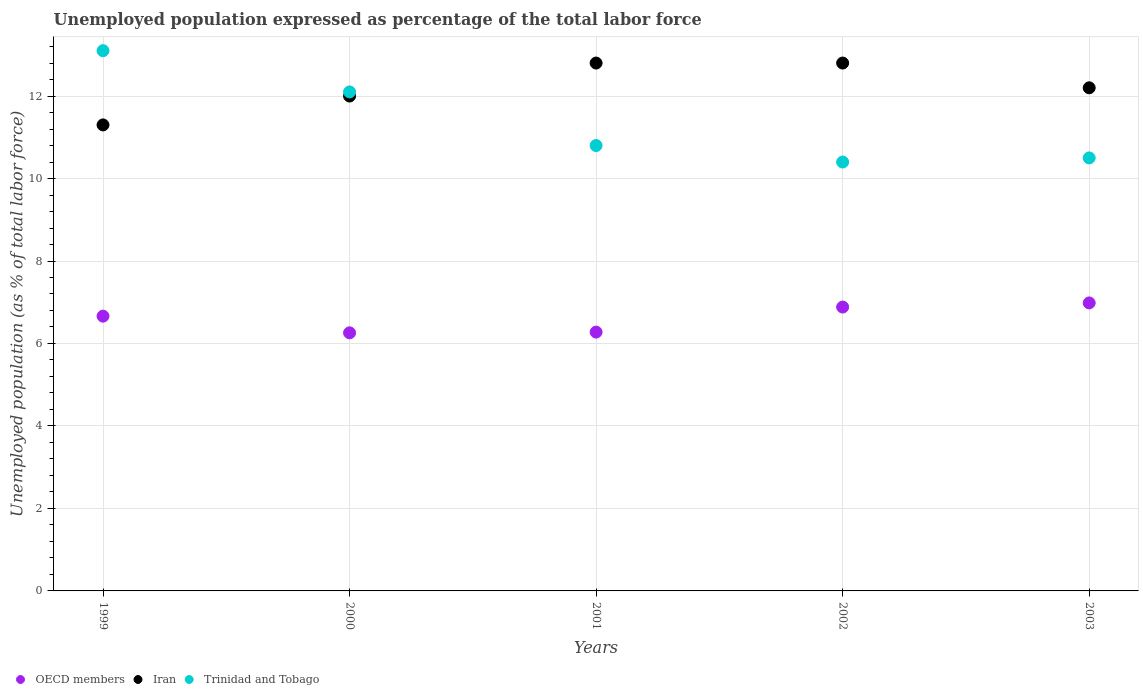What is the unemployment in in Iran in 2001?
Ensure brevity in your answer.  12.8. Across all years, what is the maximum unemployment in in OECD members?
Offer a very short reply. 6.98. Across all years, what is the minimum unemployment in in OECD members?
Offer a terse response. 6.26. In which year was the unemployment in in Trinidad and Tobago maximum?
Ensure brevity in your answer.  1999. What is the total unemployment in in Iran in the graph?
Keep it short and to the point. 61.1. What is the difference between the unemployment in in Trinidad and Tobago in 2000 and that in 2003?
Offer a very short reply. 1.6. What is the difference between the unemployment in in Trinidad and Tobago in 2002 and the unemployment in in OECD members in 1999?
Keep it short and to the point. 3.74. What is the average unemployment in in OECD members per year?
Your response must be concise. 6.61. In the year 1999, what is the difference between the unemployment in in Trinidad and Tobago and unemployment in in OECD members?
Your response must be concise. 6.44. What is the ratio of the unemployment in in OECD members in 2002 to that in 2003?
Offer a terse response. 0.99. Is the difference between the unemployment in in Trinidad and Tobago in 2001 and 2003 greater than the difference between the unemployment in in OECD members in 2001 and 2003?
Your response must be concise. Yes. What is the difference between the highest and the second highest unemployment in in OECD members?
Offer a terse response. 0.1. Is the sum of the unemployment in in Iran in 2001 and 2003 greater than the maximum unemployment in in OECD members across all years?
Offer a very short reply. Yes. Is it the case that in every year, the sum of the unemployment in in Iran and unemployment in in Trinidad and Tobago  is greater than the unemployment in in OECD members?
Your answer should be very brief. Yes. Does the unemployment in in Trinidad and Tobago monotonically increase over the years?
Offer a terse response. No. Is the unemployment in in Iran strictly greater than the unemployment in in Trinidad and Tobago over the years?
Offer a very short reply. No. What is the difference between two consecutive major ticks on the Y-axis?
Provide a short and direct response. 2. Where does the legend appear in the graph?
Ensure brevity in your answer.  Bottom left. What is the title of the graph?
Your answer should be compact. Unemployed population expressed as percentage of the total labor force. Does "Curacao" appear as one of the legend labels in the graph?
Your response must be concise. No. What is the label or title of the Y-axis?
Give a very brief answer. Unemployed population (as % of total labor force). What is the Unemployed population (as % of total labor force) in OECD members in 1999?
Your response must be concise. 6.66. What is the Unemployed population (as % of total labor force) of Iran in 1999?
Keep it short and to the point. 11.3. What is the Unemployed population (as % of total labor force) in Trinidad and Tobago in 1999?
Your answer should be very brief. 13.1. What is the Unemployed population (as % of total labor force) of OECD members in 2000?
Your answer should be very brief. 6.26. What is the Unemployed population (as % of total labor force) in Trinidad and Tobago in 2000?
Keep it short and to the point. 12.1. What is the Unemployed population (as % of total labor force) of OECD members in 2001?
Ensure brevity in your answer.  6.28. What is the Unemployed population (as % of total labor force) in Iran in 2001?
Make the answer very short. 12.8. What is the Unemployed population (as % of total labor force) in Trinidad and Tobago in 2001?
Ensure brevity in your answer.  10.8. What is the Unemployed population (as % of total labor force) of OECD members in 2002?
Ensure brevity in your answer.  6.88. What is the Unemployed population (as % of total labor force) of Iran in 2002?
Provide a succinct answer. 12.8. What is the Unemployed population (as % of total labor force) of Trinidad and Tobago in 2002?
Ensure brevity in your answer.  10.4. What is the Unemployed population (as % of total labor force) in OECD members in 2003?
Your response must be concise. 6.98. What is the Unemployed population (as % of total labor force) in Iran in 2003?
Give a very brief answer. 12.2. What is the Unemployed population (as % of total labor force) in Trinidad and Tobago in 2003?
Provide a succinct answer. 10.5. Across all years, what is the maximum Unemployed population (as % of total labor force) of OECD members?
Provide a succinct answer. 6.98. Across all years, what is the maximum Unemployed population (as % of total labor force) of Iran?
Ensure brevity in your answer.  12.8. Across all years, what is the maximum Unemployed population (as % of total labor force) of Trinidad and Tobago?
Ensure brevity in your answer.  13.1. Across all years, what is the minimum Unemployed population (as % of total labor force) in OECD members?
Offer a very short reply. 6.26. Across all years, what is the minimum Unemployed population (as % of total labor force) in Iran?
Give a very brief answer. 11.3. Across all years, what is the minimum Unemployed population (as % of total labor force) in Trinidad and Tobago?
Ensure brevity in your answer.  10.4. What is the total Unemployed population (as % of total labor force) of OECD members in the graph?
Your answer should be very brief. 33.06. What is the total Unemployed population (as % of total labor force) of Iran in the graph?
Your response must be concise. 61.1. What is the total Unemployed population (as % of total labor force) in Trinidad and Tobago in the graph?
Your answer should be very brief. 56.9. What is the difference between the Unemployed population (as % of total labor force) of OECD members in 1999 and that in 2000?
Your response must be concise. 0.4. What is the difference between the Unemployed population (as % of total labor force) in OECD members in 1999 and that in 2001?
Provide a succinct answer. 0.39. What is the difference between the Unemployed population (as % of total labor force) in Trinidad and Tobago in 1999 and that in 2001?
Your answer should be very brief. 2.3. What is the difference between the Unemployed population (as % of total labor force) of OECD members in 1999 and that in 2002?
Provide a succinct answer. -0.22. What is the difference between the Unemployed population (as % of total labor force) of Trinidad and Tobago in 1999 and that in 2002?
Provide a short and direct response. 2.7. What is the difference between the Unemployed population (as % of total labor force) in OECD members in 1999 and that in 2003?
Your answer should be very brief. -0.32. What is the difference between the Unemployed population (as % of total labor force) of Iran in 1999 and that in 2003?
Your response must be concise. -0.9. What is the difference between the Unemployed population (as % of total labor force) in OECD members in 2000 and that in 2001?
Your response must be concise. -0.02. What is the difference between the Unemployed population (as % of total labor force) of Iran in 2000 and that in 2001?
Your answer should be very brief. -0.8. What is the difference between the Unemployed population (as % of total labor force) in OECD members in 2000 and that in 2002?
Make the answer very short. -0.62. What is the difference between the Unemployed population (as % of total labor force) of OECD members in 2000 and that in 2003?
Give a very brief answer. -0.72. What is the difference between the Unemployed population (as % of total labor force) in Trinidad and Tobago in 2000 and that in 2003?
Provide a succinct answer. 1.6. What is the difference between the Unemployed population (as % of total labor force) of OECD members in 2001 and that in 2002?
Ensure brevity in your answer.  -0.61. What is the difference between the Unemployed population (as % of total labor force) of Iran in 2001 and that in 2002?
Keep it short and to the point. 0. What is the difference between the Unemployed population (as % of total labor force) in Trinidad and Tobago in 2001 and that in 2002?
Offer a very short reply. 0.4. What is the difference between the Unemployed population (as % of total labor force) in OECD members in 2001 and that in 2003?
Your response must be concise. -0.71. What is the difference between the Unemployed population (as % of total labor force) of Iran in 2001 and that in 2003?
Provide a succinct answer. 0.6. What is the difference between the Unemployed population (as % of total labor force) in Trinidad and Tobago in 2001 and that in 2003?
Ensure brevity in your answer.  0.3. What is the difference between the Unemployed population (as % of total labor force) in OECD members in 2002 and that in 2003?
Keep it short and to the point. -0.1. What is the difference between the Unemployed population (as % of total labor force) in Iran in 2002 and that in 2003?
Give a very brief answer. 0.6. What is the difference between the Unemployed population (as % of total labor force) in Trinidad and Tobago in 2002 and that in 2003?
Your answer should be very brief. -0.1. What is the difference between the Unemployed population (as % of total labor force) in OECD members in 1999 and the Unemployed population (as % of total labor force) in Iran in 2000?
Make the answer very short. -5.34. What is the difference between the Unemployed population (as % of total labor force) of OECD members in 1999 and the Unemployed population (as % of total labor force) of Trinidad and Tobago in 2000?
Keep it short and to the point. -5.44. What is the difference between the Unemployed population (as % of total labor force) of OECD members in 1999 and the Unemployed population (as % of total labor force) of Iran in 2001?
Offer a terse response. -6.14. What is the difference between the Unemployed population (as % of total labor force) of OECD members in 1999 and the Unemployed population (as % of total labor force) of Trinidad and Tobago in 2001?
Offer a terse response. -4.14. What is the difference between the Unemployed population (as % of total labor force) of Iran in 1999 and the Unemployed population (as % of total labor force) of Trinidad and Tobago in 2001?
Offer a terse response. 0.5. What is the difference between the Unemployed population (as % of total labor force) in OECD members in 1999 and the Unemployed population (as % of total labor force) in Iran in 2002?
Provide a succinct answer. -6.14. What is the difference between the Unemployed population (as % of total labor force) in OECD members in 1999 and the Unemployed population (as % of total labor force) in Trinidad and Tobago in 2002?
Offer a terse response. -3.74. What is the difference between the Unemployed population (as % of total labor force) of Iran in 1999 and the Unemployed population (as % of total labor force) of Trinidad and Tobago in 2002?
Keep it short and to the point. 0.9. What is the difference between the Unemployed population (as % of total labor force) of OECD members in 1999 and the Unemployed population (as % of total labor force) of Iran in 2003?
Your answer should be compact. -5.54. What is the difference between the Unemployed population (as % of total labor force) in OECD members in 1999 and the Unemployed population (as % of total labor force) in Trinidad and Tobago in 2003?
Your answer should be very brief. -3.84. What is the difference between the Unemployed population (as % of total labor force) of OECD members in 2000 and the Unemployed population (as % of total labor force) of Iran in 2001?
Your answer should be compact. -6.54. What is the difference between the Unemployed population (as % of total labor force) in OECD members in 2000 and the Unemployed population (as % of total labor force) in Trinidad and Tobago in 2001?
Offer a terse response. -4.54. What is the difference between the Unemployed population (as % of total labor force) of Iran in 2000 and the Unemployed population (as % of total labor force) of Trinidad and Tobago in 2001?
Make the answer very short. 1.2. What is the difference between the Unemployed population (as % of total labor force) in OECD members in 2000 and the Unemployed population (as % of total labor force) in Iran in 2002?
Your response must be concise. -6.54. What is the difference between the Unemployed population (as % of total labor force) of OECD members in 2000 and the Unemployed population (as % of total labor force) of Trinidad and Tobago in 2002?
Make the answer very short. -4.14. What is the difference between the Unemployed population (as % of total labor force) in Iran in 2000 and the Unemployed population (as % of total labor force) in Trinidad and Tobago in 2002?
Keep it short and to the point. 1.6. What is the difference between the Unemployed population (as % of total labor force) of OECD members in 2000 and the Unemployed population (as % of total labor force) of Iran in 2003?
Give a very brief answer. -5.94. What is the difference between the Unemployed population (as % of total labor force) of OECD members in 2000 and the Unemployed population (as % of total labor force) of Trinidad and Tobago in 2003?
Give a very brief answer. -4.24. What is the difference between the Unemployed population (as % of total labor force) of OECD members in 2001 and the Unemployed population (as % of total labor force) of Iran in 2002?
Your answer should be very brief. -6.52. What is the difference between the Unemployed population (as % of total labor force) in OECD members in 2001 and the Unemployed population (as % of total labor force) in Trinidad and Tobago in 2002?
Provide a succinct answer. -4.12. What is the difference between the Unemployed population (as % of total labor force) in OECD members in 2001 and the Unemployed population (as % of total labor force) in Iran in 2003?
Offer a very short reply. -5.92. What is the difference between the Unemployed population (as % of total labor force) of OECD members in 2001 and the Unemployed population (as % of total labor force) of Trinidad and Tobago in 2003?
Provide a succinct answer. -4.22. What is the difference between the Unemployed population (as % of total labor force) in OECD members in 2002 and the Unemployed population (as % of total labor force) in Iran in 2003?
Offer a terse response. -5.32. What is the difference between the Unemployed population (as % of total labor force) of OECD members in 2002 and the Unemployed population (as % of total labor force) of Trinidad and Tobago in 2003?
Keep it short and to the point. -3.62. What is the average Unemployed population (as % of total labor force) in OECD members per year?
Your response must be concise. 6.61. What is the average Unemployed population (as % of total labor force) in Iran per year?
Offer a very short reply. 12.22. What is the average Unemployed population (as % of total labor force) of Trinidad and Tobago per year?
Provide a succinct answer. 11.38. In the year 1999, what is the difference between the Unemployed population (as % of total labor force) of OECD members and Unemployed population (as % of total labor force) of Iran?
Offer a terse response. -4.64. In the year 1999, what is the difference between the Unemployed population (as % of total labor force) in OECD members and Unemployed population (as % of total labor force) in Trinidad and Tobago?
Offer a terse response. -6.44. In the year 2000, what is the difference between the Unemployed population (as % of total labor force) in OECD members and Unemployed population (as % of total labor force) in Iran?
Provide a short and direct response. -5.74. In the year 2000, what is the difference between the Unemployed population (as % of total labor force) in OECD members and Unemployed population (as % of total labor force) in Trinidad and Tobago?
Ensure brevity in your answer.  -5.84. In the year 2000, what is the difference between the Unemployed population (as % of total labor force) in Iran and Unemployed population (as % of total labor force) in Trinidad and Tobago?
Ensure brevity in your answer.  -0.1. In the year 2001, what is the difference between the Unemployed population (as % of total labor force) in OECD members and Unemployed population (as % of total labor force) in Iran?
Give a very brief answer. -6.52. In the year 2001, what is the difference between the Unemployed population (as % of total labor force) in OECD members and Unemployed population (as % of total labor force) in Trinidad and Tobago?
Your answer should be compact. -4.52. In the year 2002, what is the difference between the Unemployed population (as % of total labor force) in OECD members and Unemployed population (as % of total labor force) in Iran?
Offer a terse response. -5.92. In the year 2002, what is the difference between the Unemployed population (as % of total labor force) in OECD members and Unemployed population (as % of total labor force) in Trinidad and Tobago?
Make the answer very short. -3.52. In the year 2003, what is the difference between the Unemployed population (as % of total labor force) in OECD members and Unemployed population (as % of total labor force) in Iran?
Keep it short and to the point. -5.22. In the year 2003, what is the difference between the Unemployed population (as % of total labor force) of OECD members and Unemployed population (as % of total labor force) of Trinidad and Tobago?
Give a very brief answer. -3.52. What is the ratio of the Unemployed population (as % of total labor force) of OECD members in 1999 to that in 2000?
Your response must be concise. 1.06. What is the ratio of the Unemployed population (as % of total labor force) in Iran in 1999 to that in 2000?
Ensure brevity in your answer.  0.94. What is the ratio of the Unemployed population (as % of total labor force) in Trinidad and Tobago in 1999 to that in 2000?
Make the answer very short. 1.08. What is the ratio of the Unemployed population (as % of total labor force) of OECD members in 1999 to that in 2001?
Provide a succinct answer. 1.06. What is the ratio of the Unemployed population (as % of total labor force) of Iran in 1999 to that in 2001?
Provide a succinct answer. 0.88. What is the ratio of the Unemployed population (as % of total labor force) of Trinidad and Tobago in 1999 to that in 2001?
Provide a succinct answer. 1.21. What is the ratio of the Unemployed population (as % of total labor force) of OECD members in 1999 to that in 2002?
Your answer should be compact. 0.97. What is the ratio of the Unemployed population (as % of total labor force) of Iran in 1999 to that in 2002?
Your answer should be very brief. 0.88. What is the ratio of the Unemployed population (as % of total labor force) in Trinidad and Tobago in 1999 to that in 2002?
Keep it short and to the point. 1.26. What is the ratio of the Unemployed population (as % of total labor force) in OECD members in 1999 to that in 2003?
Offer a very short reply. 0.95. What is the ratio of the Unemployed population (as % of total labor force) of Iran in 1999 to that in 2003?
Your answer should be compact. 0.93. What is the ratio of the Unemployed population (as % of total labor force) in Trinidad and Tobago in 1999 to that in 2003?
Provide a succinct answer. 1.25. What is the ratio of the Unemployed population (as % of total labor force) in Trinidad and Tobago in 2000 to that in 2001?
Offer a very short reply. 1.12. What is the ratio of the Unemployed population (as % of total labor force) in OECD members in 2000 to that in 2002?
Keep it short and to the point. 0.91. What is the ratio of the Unemployed population (as % of total labor force) of Trinidad and Tobago in 2000 to that in 2002?
Keep it short and to the point. 1.16. What is the ratio of the Unemployed population (as % of total labor force) of OECD members in 2000 to that in 2003?
Keep it short and to the point. 0.9. What is the ratio of the Unemployed population (as % of total labor force) of Iran in 2000 to that in 2003?
Provide a succinct answer. 0.98. What is the ratio of the Unemployed population (as % of total labor force) of Trinidad and Tobago in 2000 to that in 2003?
Give a very brief answer. 1.15. What is the ratio of the Unemployed population (as % of total labor force) in OECD members in 2001 to that in 2002?
Keep it short and to the point. 0.91. What is the ratio of the Unemployed population (as % of total labor force) of OECD members in 2001 to that in 2003?
Offer a very short reply. 0.9. What is the ratio of the Unemployed population (as % of total labor force) of Iran in 2001 to that in 2003?
Your answer should be very brief. 1.05. What is the ratio of the Unemployed population (as % of total labor force) of Trinidad and Tobago in 2001 to that in 2003?
Provide a succinct answer. 1.03. What is the ratio of the Unemployed population (as % of total labor force) in OECD members in 2002 to that in 2003?
Offer a terse response. 0.99. What is the ratio of the Unemployed population (as % of total labor force) of Iran in 2002 to that in 2003?
Keep it short and to the point. 1.05. What is the ratio of the Unemployed population (as % of total labor force) in Trinidad and Tobago in 2002 to that in 2003?
Offer a very short reply. 0.99. What is the difference between the highest and the second highest Unemployed population (as % of total labor force) in OECD members?
Ensure brevity in your answer.  0.1. What is the difference between the highest and the second highest Unemployed population (as % of total labor force) of Iran?
Give a very brief answer. 0. What is the difference between the highest and the lowest Unemployed population (as % of total labor force) in OECD members?
Your response must be concise. 0.72. What is the difference between the highest and the lowest Unemployed population (as % of total labor force) in Iran?
Offer a very short reply. 1.5. What is the difference between the highest and the lowest Unemployed population (as % of total labor force) of Trinidad and Tobago?
Offer a very short reply. 2.7. 